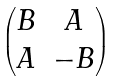<formula> <loc_0><loc_0><loc_500><loc_500>\begin{pmatrix} B & A \\ A & - B \end{pmatrix}</formula> 